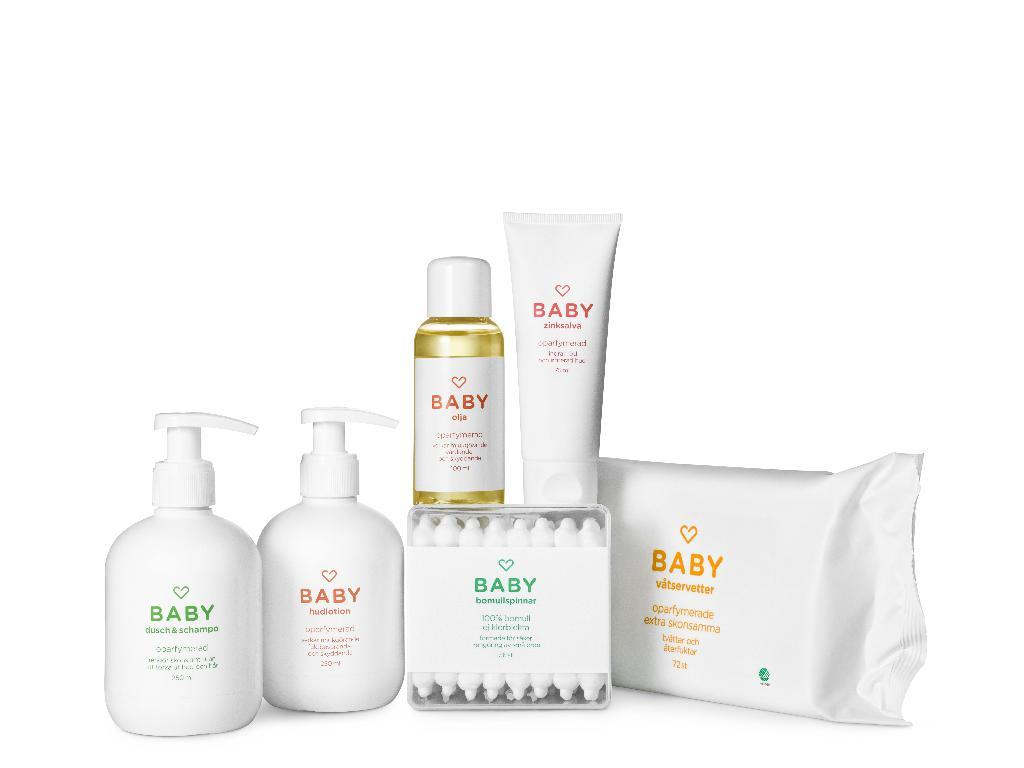Provide a one-sentence caption for the provided image. Various baby products such as shampoo and lotion. 